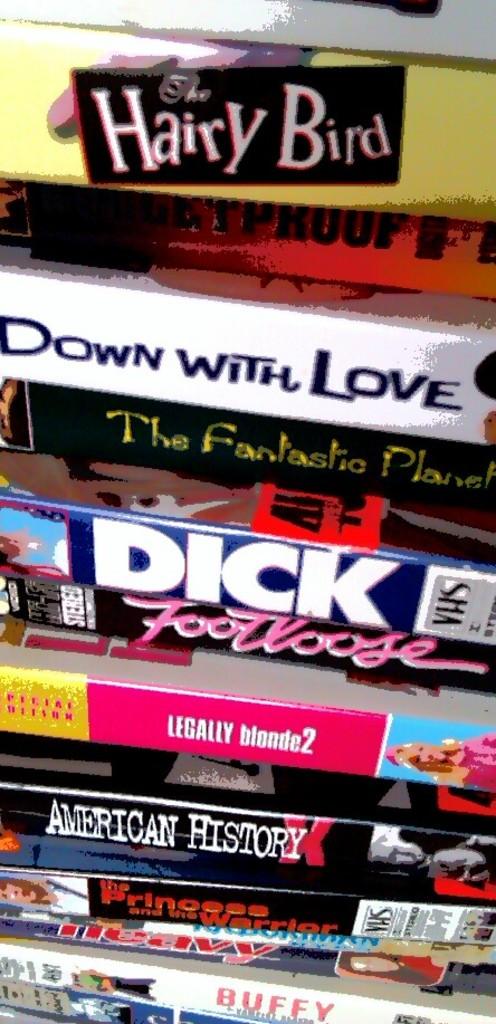What is the name of a movie?
Keep it short and to the point. Footloose. What is the top dvd?
Keep it short and to the point. Hairy bird. 